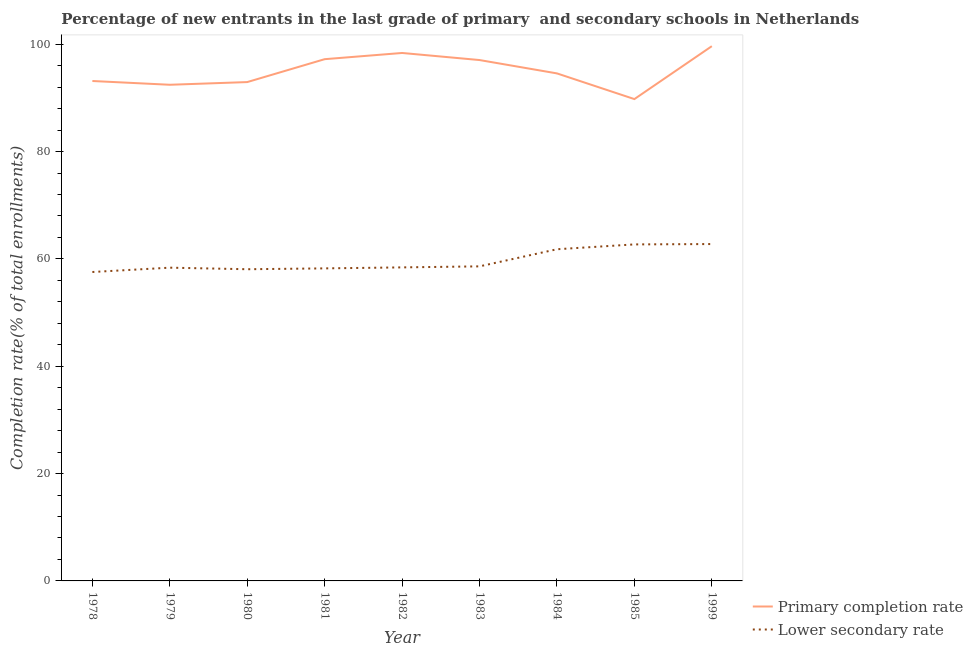How many different coloured lines are there?
Keep it short and to the point. 2. Is the number of lines equal to the number of legend labels?
Provide a succinct answer. Yes. What is the completion rate in primary schools in 1983?
Offer a very short reply. 97.05. Across all years, what is the maximum completion rate in secondary schools?
Offer a terse response. 62.77. Across all years, what is the minimum completion rate in primary schools?
Offer a terse response. 89.78. In which year was the completion rate in secondary schools minimum?
Your response must be concise. 1978. What is the total completion rate in secondary schools in the graph?
Your response must be concise. 536.54. What is the difference between the completion rate in secondary schools in 1985 and that in 1999?
Your answer should be compact. -0.07. What is the difference between the completion rate in primary schools in 1983 and the completion rate in secondary schools in 1999?
Keep it short and to the point. 34.28. What is the average completion rate in secondary schools per year?
Your response must be concise. 59.62. In the year 1999, what is the difference between the completion rate in primary schools and completion rate in secondary schools?
Your response must be concise. 36.87. What is the ratio of the completion rate in secondary schools in 1978 to that in 1999?
Offer a terse response. 0.92. What is the difference between the highest and the second highest completion rate in secondary schools?
Your response must be concise. 0.07. What is the difference between the highest and the lowest completion rate in primary schools?
Provide a succinct answer. 9.86. In how many years, is the completion rate in secondary schools greater than the average completion rate in secondary schools taken over all years?
Your answer should be compact. 3. Is the completion rate in primary schools strictly less than the completion rate in secondary schools over the years?
Ensure brevity in your answer.  No. How many lines are there?
Ensure brevity in your answer.  2. How many years are there in the graph?
Provide a short and direct response. 9. What is the difference between two consecutive major ticks on the Y-axis?
Your answer should be very brief. 20. Are the values on the major ticks of Y-axis written in scientific E-notation?
Your answer should be compact. No. Does the graph contain any zero values?
Give a very brief answer. No. Does the graph contain grids?
Provide a succinct answer. No. Where does the legend appear in the graph?
Offer a terse response. Bottom right. How many legend labels are there?
Your response must be concise. 2. What is the title of the graph?
Offer a very short reply. Percentage of new entrants in the last grade of primary  and secondary schools in Netherlands. What is the label or title of the X-axis?
Provide a succinct answer. Year. What is the label or title of the Y-axis?
Keep it short and to the point. Completion rate(% of total enrollments). What is the Completion rate(% of total enrollments) in Primary completion rate in 1978?
Provide a short and direct response. 93.15. What is the Completion rate(% of total enrollments) in Lower secondary rate in 1978?
Your answer should be compact. 57.56. What is the Completion rate(% of total enrollments) in Primary completion rate in 1979?
Keep it short and to the point. 92.45. What is the Completion rate(% of total enrollments) in Lower secondary rate in 1979?
Keep it short and to the point. 58.37. What is the Completion rate(% of total enrollments) of Primary completion rate in 1980?
Keep it short and to the point. 92.95. What is the Completion rate(% of total enrollments) in Lower secondary rate in 1980?
Ensure brevity in your answer.  58.08. What is the Completion rate(% of total enrollments) of Primary completion rate in 1981?
Ensure brevity in your answer.  97.21. What is the Completion rate(% of total enrollments) in Lower secondary rate in 1981?
Your answer should be compact. 58.23. What is the Completion rate(% of total enrollments) of Primary completion rate in 1982?
Give a very brief answer. 98.37. What is the Completion rate(% of total enrollments) in Lower secondary rate in 1982?
Your answer should be compact. 58.42. What is the Completion rate(% of total enrollments) of Primary completion rate in 1983?
Your answer should be very brief. 97.05. What is the Completion rate(% of total enrollments) of Lower secondary rate in 1983?
Keep it short and to the point. 58.61. What is the Completion rate(% of total enrollments) of Primary completion rate in 1984?
Ensure brevity in your answer.  94.56. What is the Completion rate(% of total enrollments) in Lower secondary rate in 1984?
Your response must be concise. 61.8. What is the Completion rate(% of total enrollments) in Primary completion rate in 1985?
Offer a very short reply. 89.78. What is the Completion rate(% of total enrollments) in Lower secondary rate in 1985?
Your response must be concise. 62.7. What is the Completion rate(% of total enrollments) of Primary completion rate in 1999?
Provide a succinct answer. 99.64. What is the Completion rate(% of total enrollments) of Lower secondary rate in 1999?
Your answer should be very brief. 62.77. Across all years, what is the maximum Completion rate(% of total enrollments) of Primary completion rate?
Your answer should be very brief. 99.64. Across all years, what is the maximum Completion rate(% of total enrollments) in Lower secondary rate?
Provide a short and direct response. 62.77. Across all years, what is the minimum Completion rate(% of total enrollments) of Primary completion rate?
Your answer should be compact. 89.78. Across all years, what is the minimum Completion rate(% of total enrollments) of Lower secondary rate?
Keep it short and to the point. 57.56. What is the total Completion rate(% of total enrollments) in Primary completion rate in the graph?
Provide a short and direct response. 855.16. What is the total Completion rate(% of total enrollments) in Lower secondary rate in the graph?
Give a very brief answer. 536.54. What is the difference between the Completion rate(% of total enrollments) of Primary completion rate in 1978 and that in 1979?
Ensure brevity in your answer.  0.7. What is the difference between the Completion rate(% of total enrollments) in Lower secondary rate in 1978 and that in 1979?
Your response must be concise. -0.81. What is the difference between the Completion rate(% of total enrollments) of Primary completion rate in 1978 and that in 1980?
Provide a succinct answer. 0.2. What is the difference between the Completion rate(% of total enrollments) in Lower secondary rate in 1978 and that in 1980?
Keep it short and to the point. -0.52. What is the difference between the Completion rate(% of total enrollments) of Primary completion rate in 1978 and that in 1981?
Offer a terse response. -4.07. What is the difference between the Completion rate(% of total enrollments) in Lower secondary rate in 1978 and that in 1981?
Provide a short and direct response. -0.67. What is the difference between the Completion rate(% of total enrollments) of Primary completion rate in 1978 and that in 1982?
Offer a terse response. -5.22. What is the difference between the Completion rate(% of total enrollments) of Lower secondary rate in 1978 and that in 1982?
Offer a very short reply. -0.86. What is the difference between the Completion rate(% of total enrollments) of Primary completion rate in 1978 and that in 1983?
Provide a succinct answer. -3.9. What is the difference between the Completion rate(% of total enrollments) in Lower secondary rate in 1978 and that in 1983?
Your answer should be compact. -1.05. What is the difference between the Completion rate(% of total enrollments) of Primary completion rate in 1978 and that in 1984?
Your response must be concise. -1.42. What is the difference between the Completion rate(% of total enrollments) of Lower secondary rate in 1978 and that in 1984?
Offer a very short reply. -4.24. What is the difference between the Completion rate(% of total enrollments) of Primary completion rate in 1978 and that in 1985?
Your answer should be very brief. 3.37. What is the difference between the Completion rate(% of total enrollments) in Lower secondary rate in 1978 and that in 1985?
Provide a succinct answer. -5.14. What is the difference between the Completion rate(% of total enrollments) in Primary completion rate in 1978 and that in 1999?
Provide a succinct answer. -6.49. What is the difference between the Completion rate(% of total enrollments) of Lower secondary rate in 1978 and that in 1999?
Give a very brief answer. -5.21. What is the difference between the Completion rate(% of total enrollments) of Primary completion rate in 1979 and that in 1980?
Ensure brevity in your answer.  -0.5. What is the difference between the Completion rate(% of total enrollments) in Lower secondary rate in 1979 and that in 1980?
Offer a terse response. 0.29. What is the difference between the Completion rate(% of total enrollments) of Primary completion rate in 1979 and that in 1981?
Keep it short and to the point. -4.77. What is the difference between the Completion rate(% of total enrollments) of Lower secondary rate in 1979 and that in 1981?
Keep it short and to the point. 0.13. What is the difference between the Completion rate(% of total enrollments) of Primary completion rate in 1979 and that in 1982?
Your answer should be very brief. -5.92. What is the difference between the Completion rate(% of total enrollments) of Lower secondary rate in 1979 and that in 1982?
Keep it short and to the point. -0.05. What is the difference between the Completion rate(% of total enrollments) in Primary completion rate in 1979 and that in 1983?
Offer a very short reply. -4.6. What is the difference between the Completion rate(% of total enrollments) in Lower secondary rate in 1979 and that in 1983?
Your answer should be compact. -0.24. What is the difference between the Completion rate(% of total enrollments) in Primary completion rate in 1979 and that in 1984?
Keep it short and to the point. -2.12. What is the difference between the Completion rate(% of total enrollments) of Lower secondary rate in 1979 and that in 1984?
Offer a terse response. -3.43. What is the difference between the Completion rate(% of total enrollments) in Primary completion rate in 1979 and that in 1985?
Provide a short and direct response. 2.67. What is the difference between the Completion rate(% of total enrollments) of Lower secondary rate in 1979 and that in 1985?
Give a very brief answer. -4.34. What is the difference between the Completion rate(% of total enrollments) of Primary completion rate in 1979 and that in 1999?
Ensure brevity in your answer.  -7.19. What is the difference between the Completion rate(% of total enrollments) of Lower secondary rate in 1979 and that in 1999?
Offer a terse response. -4.4. What is the difference between the Completion rate(% of total enrollments) in Primary completion rate in 1980 and that in 1981?
Your answer should be very brief. -4.27. What is the difference between the Completion rate(% of total enrollments) in Lower secondary rate in 1980 and that in 1981?
Make the answer very short. -0.16. What is the difference between the Completion rate(% of total enrollments) in Primary completion rate in 1980 and that in 1982?
Give a very brief answer. -5.42. What is the difference between the Completion rate(% of total enrollments) of Lower secondary rate in 1980 and that in 1982?
Your answer should be compact. -0.34. What is the difference between the Completion rate(% of total enrollments) in Primary completion rate in 1980 and that in 1983?
Your answer should be very brief. -4.1. What is the difference between the Completion rate(% of total enrollments) of Lower secondary rate in 1980 and that in 1983?
Offer a terse response. -0.54. What is the difference between the Completion rate(% of total enrollments) of Primary completion rate in 1980 and that in 1984?
Offer a very short reply. -1.62. What is the difference between the Completion rate(% of total enrollments) in Lower secondary rate in 1980 and that in 1984?
Offer a very short reply. -3.72. What is the difference between the Completion rate(% of total enrollments) in Primary completion rate in 1980 and that in 1985?
Keep it short and to the point. 3.17. What is the difference between the Completion rate(% of total enrollments) of Lower secondary rate in 1980 and that in 1985?
Your response must be concise. -4.63. What is the difference between the Completion rate(% of total enrollments) of Primary completion rate in 1980 and that in 1999?
Your answer should be compact. -6.69. What is the difference between the Completion rate(% of total enrollments) of Lower secondary rate in 1980 and that in 1999?
Keep it short and to the point. -4.69. What is the difference between the Completion rate(% of total enrollments) of Primary completion rate in 1981 and that in 1982?
Ensure brevity in your answer.  -1.16. What is the difference between the Completion rate(% of total enrollments) of Lower secondary rate in 1981 and that in 1982?
Give a very brief answer. -0.18. What is the difference between the Completion rate(% of total enrollments) in Primary completion rate in 1981 and that in 1983?
Provide a short and direct response. 0.16. What is the difference between the Completion rate(% of total enrollments) in Lower secondary rate in 1981 and that in 1983?
Provide a succinct answer. -0.38. What is the difference between the Completion rate(% of total enrollments) of Primary completion rate in 1981 and that in 1984?
Offer a terse response. 2.65. What is the difference between the Completion rate(% of total enrollments) in Lower secondary rate in 1981 and that in 1984?
Offer a terse response. -3.56. What is the difference between the Completion rate(% of total enrollments) in Primary completion rate in 1981 and that in 1985?
Provide a succinct answer. 7.44. What is the difference between the Completion rate(% of total enrollments) in Lower secondary rate in 1981 and that in 1985?
Your response must be concise. -4.47. What is the difference between the Completion rate(% of total enrollments) of Primary completion rate in 1981 and that in 1999?
Keep it short and to the point. -2.42. What is the difference between the Completion rate(% of total enrollments) of Lower secondary rate in 1981 and that in 1999?
Your answer should be compact. -4.53. What is the difference between the Completion rate(% of total enrollments) of Primary completion rate in 1982 and that in 1983?
Ensure brevity in your answer.  1.32. What is the difference between the Completion rate(% of total enrollments) of Lower secondary rate in 1982 and that in 1983?
Your response must be concise. -0.19. What is the difference between the Completion rate(% of total enrollments) of Primary completion rate in 1982 and that in 1984?
Your answer should be compact. 3.81. What is the difference between the Completion rate(% of total enrollments) of Lower secondary rate in 1982 and that in 1984?
Offer a terse response. -3.38. What is the difference between the Completion rate(% of total enrollments) of Primary completion rate in 1982 and that in 1985?
Provide a succinct answer. 8.59. What is the difference between the Completion rate(% of total enrollments) of Lower secondary rate in 1982 and that in 1985?
Offer a very short reply. -4.28. What is the difference between the Completion rate(% of total enrollments) of Primary completion rate in 1982 and that in 1999?
Keep it short and to the point. -1.27. What is the difference between the Completion rate(% of total enrollments) in Lower secondary rate in 1982 and that in 1999?
Offer a very short reply. -4.35. What is the difference between the Completion rate(% of total enrollments) in Primary completion rate in 1983 and that in 1984?
Keep it short and to the point. 2.49. What is the difference between the Completion rate(% of total enrollments) in Lower secondary rate in 1983 and that in 1984?
Ensure brevity in your answer.  -3.19. What is the difference between the Completion rate(% of total enrollments) of Primary completion rate in 1983 and that in 1985?
Keep it short and to the point. 7.27. What is the difference between the Completion rate(% of total enrollments) in Lower secondary rate in 1983 and that in 1985?
Your response must be concise. -4.09. What is the difference between the Completion rate(% of total enrollments) of Primary completion rate in 1983 and that in 1999?
Offer a very short reply. -2.59. What is the difference between the Completion rate(% of total enrollments) of Lower secondary rate in 1983 and that in 1999?
Offer a very short reply. -4.16. What is the difference between the Completion rate(% of total enrollments) in Primary completion rate in 1984 and that in 1985?
Your answer should be compact. 4.79. What is the difference between the Completion rate(% of total enrollments) in Lower secondary rate in 1984 and that in 1985?
Provide a short and direct response. -0.9. What is the difference between the Completion rate(% of total enrollments) of Primary completion rate in 1984 and that in 1999?
Your answer should be very brief. -5.07. What is the difference between the Completion rate(% of total enrollments) of Lower secondary rate in 1984 and that in 1999?
Keep it short and to the point. -0.97. What is the difference between the Completion rate(% of total enrollments) of Primary completion rate in 1985 and that in 1999?
Your answer should be very brief. -9.86. What is the difference between the Completion rate(% of total enrollments) in Lower secondary rate in 1985 and that in 1999?
Your response must be concise. -0.07. What is the difference between the Completion rate(% of total enrollments) of Primary completion rate in 1978 and the Completion rate(% of total enrollments) of Lower secondary rate in 1979?
Offer a very short reply. 34.78. What is the difference between the Completion rate(% of total enrollments) of Primary completion rate in 1978 and the Completion rate(% of total enrollments) of Lower secondary rate in 1980?
Give a very brief answer. 35.07. What is the difference between the Completion rate(% of total enrollments) in Primary completion rate in 1978 and the Completion rate(% of total enrollments) in Lower secondary rate in 1981?
Ensure brevity in your answer.  34.91. What is the difference between the Completion rate(% of total enrollments) of Primary completion rate in 1978 and the Completion rate(% of total enrollments) of Lower secondary rate in 1982?
Make the answer very short. 34.73. What is the difference between the Completion rate(% of total enrollments) of Primary completion rate in 1978 and the Completion rate(% of total enrollments) of Lower secondary rate in 1983?
Offer a very short reply. 34.54. What is the difference between the Completion rate(% of total enrollments) in Primary completion rate in 1978 and the Completion rate(% of total enrollments) in Lower secondary rate in 1984?
Ensure brevity in your answer.  31.35. What is the difference between the Completion rate(% of total enrollments) of Primary completion rate in 1978 and the Completion rate(% of total enrollments) of Lower secondary rate in 1985?
Give a very brief answer. 30.45. What is the difference between the Completion rate(% of total enrollments) of Primary completion rate in 1978 and the Completion rate(% of total enrollments) of Lower secondary rate in 1999?
Make the answer very short. 30.38. What is the difference between the Completion rate(% of total enrollments) of Primary completion rate in 1979 and the Completion rate(% of total enrollments) of Lower secondary rate in 1980?
Offer a terse response. 34.37. What is the difference between the Completion rate(% of total enrollments) of Primary completion rate in 1979 and the Completion rate(% of total enrollments) of Lower secondary rate in 1981?
Your answer should be very brief. 34.21. What is the difference between the Completion rate(% of total enrollments) in Primary completion rate in 1979 and the Completion rate(% of total enrollments) in Lower secondary rate in 1982?
Your response must be concise. 34.03. What is the difference between the Completion rate(% of total enrollments) of Primary completion rate in 1979 and the Completion rate(% of total enrollments) of Lower secondary rate in 1983?
Keep it short and to the point. 33.84. What is the difference between the Completion rate(% of total enrollments) of Primary completion rate in 1979 and the Completion rate(% of total enrollments) of Lower secondary rate in 1984?
Keep it short and to the point. 30.65. What is the difference between the Completion rate(% of total enrollments) of Primary completion rate in 1979 and the Completion rate(% of total enrollments) of Lower secondary rate in 1985?
Keep it short and to the point. 29.75. What is the difference between the Completion rate(% of total enrollments) in Primary completion rate in 1979 and the Completion rate(% of total enrollments) in Lower secondary rate in 1999?
Your answer should be compact. 29.68. What is the difference between the Completion rate(% of total enrollments) of Primary completion rate in 1980 and the Completion rate(% of total enrollments) of Lower secondary rate in 1981?
Your response must be concise. 34.71. What is the difference between the Completion rate(% of total enrollments) of Primary completion rate in 1980 and the Completion rate(% of total enrollments) of Lower secondary rate in 1982?
Make the answer very short. 34.53. What is the difference between the Completion rate(% of total enrollments) of Primary completion rate in 1980 and the Completion rate(% of total enrollments) of Lower secondary rate in 1983?
Your answer should be very brief. 34.34. What is the difference between the Completion rate(% of total enrollments) in Primary completion rate in 1980 and the Completion rate(% of total enrollments) in Lower secondary rate in 1984?
Provide a succinct answer. 31.15. What is the difference between the Completion rate(% of total enrollments) in Primary completion rate in 1980 and the Completion rate(% of total enrollments) in Lower secondary rate in 1985?
Keep it short and to the point. 30.25. What is the difference between the Completion rate(% of total enrollments) of Primary completion rate in 1980 and the Completion rate(% of total enrollments) of Lower secondary rate in 1999?
Offer a terse response. 30.18. What is the difference between the Completion rate(% of total enrollments) in Primary completion rate in 1981 and the Completion rate(% of total enrollments) in Lower secondary rate in 1982?
Keep it short and to the point. 38.8. What is the difference between the Completion rate(% of total enrollments) of Primary completion rate in 1981 and the Completion rate(% of total enrollments) of Lower secondary rate in 1983?
Ensure brevity in your answer.  38.6. What is the difference between the Completion rate(% of total enrollments) of Primary completion rate in 1981 and the Completion rate(% of total enrollments) of Lower secondary rate in 1984?
Provide a short and direct response. 35.41. What is the difference between the Completion rate(% of total enrollments) in Primary completion rate in 1981 and the Completion rate(% of total enrollments) in Lower secondary rate in 1985?
Ensure brevity in your answer.  34.51. What is the difference between the Completion rate(% of total enrollments) of Primary completion rate in 1981 and the Completion rate(% of total enrollments) of Lower secondary rate in 1999?
Make the answer very short. 34.45. What is the difference between the Completion rate(% of total enrollments) of Primary completion rate in 1982 and the Completion rate(% of total enrollments) of Lower secondary rate in 1983?
Make the answer very short. 39.76. What is the difference between the Completion rate(% of total enrollments) in Primary completion rate in 1982 and the Completion rate(% of total enrollments) in Lower secondary rate in 1984?
Provide a short and direct response. 36.57. What is the difference between the Completion rate(% of total enrollments) of Primary completion rate in 1982 and the Completion rate(% of total enrollments) of Lower secondary rate in 1985?
Keep it short and to the point. 35.67. What is the difference between the Completion rate(% of total enrollments) of Primary completion rate in 1982 and the Completion rate(% of total enrollments) of Lower secondary rate in 1999?
Ensure brevity in your answer.  35.6. What is the difference between the Completion rate(% of total enrollments) in Primary completion rate in 1983 and the Completion rate(% of total enrollments) in Lower secondary rate in 1984?
Give a very brief answer. 35.25. What is the difference between the Completion rate(% of total enrollments) in Primary completion rate in 1983 and the Completion rate(% of total enrollments) in Lower secondary rate in 1985?
Provide a succinct answer. 34.35. What is the difference between the Completion rate(% of total enrollments) of Primary completion rate in 1983 and the Completion rate(% of total enrollments) of Lower secondary rate in 1999?
Make the answer very short. 34.28. What is the difference between the Completion rate(% of total enrollments) in Primary completion rate in 1984 and the Completion rate(% of total enrollments) in Lower secondary rate in 1985?
Offer a terse response. 31.86. What is the difference between the Completion rate(% of total enrollments) of Primary completion rate in 1984 and the Completion rate(% of total enrollments) of Lower secondary rate in 1999?
Ensure brevity in your answer.  31.8. What is the difference between the Completion rate(% of total enrollments) in Primary completion rate in 1985 and the Completion rate(% of total enrollments) in Lower secondary rate in 1999?
Your answer should be very brief. 27.01. What is the average Completion rate(% of total enrollments) of Primary completion rate per year?
Your answer should be very brief. 95.02. What is the average Completion rate(% of total enrollments) in Lower secondary rate per year?
Your answer should be compact. 59.62. In the year 1978, what is the difference between the Completion rate(% of total enrollments) in Primary completion rate and Completion rate(% of total enrollments) in Lower secondary rate?
Your answer should be compact. 35.59. In the year 1979, what is the difference between the Completion rate(% of total enrollments) of Primary completion rate and Completion rate(% of total enrollments) of Lower secondary rate?
Your answer should be very brief. 34.08. In the year 1980, what is the difference between the Completion rate(% of total enrollments) in Primary completion rate and Completion rate(% of total enrollments) in Lower secondary rate?
Your answer should be compact. 34.87. In the year 1981, what is the difference between the Completion rate(% of total enrollments) of Primary completion rate and Completion rate(% of total enrollments) of Lower secondary rate?
Offer a terse response. 38.98. In the year 1982, what is the difference between the Completion rate(% of total enrollments) of Primary completion rate and Completion rate(% of total enrollments) of Lower secondary rate?
Keep it short and to the point. 39.95. In the year 1983, what is the difference between the Completion rate(% of total enrollments) in Primary completion rate and Completion rate(% of total enrollments) in Lower secondary rate?
Ensure brevity in your answer.  38.44. In the year 1984, what is the difference between the Completion rate(% of total enrollments) in Primary completion rate and Completion rate(% of total enrollments) in Lower secondary rate?
Give a very brief answer. 32.77. In the year 1985, what is the difference between the Completion rate(% of total enrollments) in Primary completion rate and Completion rate(% of total enrollments) in Lower secondary rate?
Your response must be concise. 27.08. In the year 1999, what is the difference between the Completion rate(% of total enrollments) of Primary completion rate and Completion rate(% of total enrollments) of Lower secondary rate?
Offer a very short reply. 36.87. What is the ratio of the Completion rate(% of total enrollments) in Primary completion rate in 1978 to that in 1979?
Offer a terse response. 1.01. What is the ratio of the Completion rate(% of total enrollments) in Lower secondary rate in 1978 to that in 1979?
Give a very brief answer. 0.99. What is the ratio of the Completion rate(% of total enrollments) in Lower secondary rate in 1978 to that in 1980?
Your answer should be compact. 0.99. What is the ratio of the Completion rate(% of total enrollments) in Primary completion rate in 1978 to that in 1981?
Provide a succinct answer. 0.96. What is the ratio of the Completion rate(% of total enrollments) of Lower secondary rate in 1978 to that in 1981?
Your answer should be compact. 0.99. What is the ratio of the Completion rate(% of total enrollments) of Primary completion rate in 1978 to that in 1982?
Offer a terse response. 0.95. What is the ratio of the Completion rate(% of total enrollments) of Primary completion rate in 1978 to that in 1983?
Ensure brevity in your answer.  0.96. What is the ratio of the Completion rate(% of total enrollments) of Lower secondary rate in 1978 to that in 1983?
Your answer should be very brief. 0.98. What is the ratio of the Completion rate(% of total enrollments) of Primary completion rate in 1978 to that in 1984?
Offer a very short reply. 0.98. What is the ratio of the Completion rate(% of total enrollments) of Lower secondary rate in 1978 to that in 1984?
Your response must be concise. 0.93. What is the ratio of the Completion rate(% of total enrollments) of Primary completion rate in 1978 to that in 1985?
Give a very brief answer. 1.04. What is the ratio of the Completion rate(% of total enrollments) in Lower secondary rate in 1978 to that in 1985?
Your answer should be compact. 0.92. What is the ratio of the Completion rate(% of total enrollments) of Primary completion rate in 1978 to that in 1999?
Give a very brief answer. 0.93. What is the ratio of the Completion rate(% of total enrollments) in Lower secondary rate in 1978 to that in 1999?
Your response must be concise. 0.92. What is the ratio of the Completion rate(% of total enrollments) in Primary completion rate in 1979 to that in 1980?
Keep it short and to the point. 0.99. What is the ratio of the Completion rate(% of total enrollments) of Primary completion rate in 1979 to that in 1981?
Make the answer very short. 0.95. What is the ratio of the Completion rate(% of total enrollments) of Primary completion rate in 1979 to that in 1982?
Offer a very short reply. 0.94. What is the ratio of the Completion rate(% of total enrollments) of Primary completion rate in 1979 to that in 1983?
Ensure brevity in your answer.  0.95. What is the ratio of the Completion rate(% of total enrollments) of Lower secondary rate in 1979 to that in 1983?
Your answer should be very brief. 1. What is the ratio of the Completion rate(% of total enrollments) of Primary completion rate in 1979 to that in 1984?
Offer a very short reply. 0.98. What is the ratio of the Completion rate(% of total enrollments) in Primary completion rate in 1979 to that in 1985?
Offer a terse response. 1.03. What is the ratio of the Completion rate(% of total enrollments) in Lower secondary rate in 1979 to that in 1985?
Provide a succinct answer. 0.93. What is the ratio of the Completion rate(% of total enrollments) of Primary completion rate in 1979 to that in 1999?
Your answer should be very brief. 0.93. What is the ratio of the Completion rate(% of total enrollments) in Lower secondary rate in 1979 to that in 1999?
Offer a very short reply. 0.93. What is the ratio of the Completion rate(% of total enrollments) in Primary completion rate in 1980 to that in 1981?
Provide a short and direct response. 0.96. What is the ratio of the Completion rate(% of total enrollments) in Primary completion rate in 1980 to that in 1982?
Keep it short and to the point. 0.94. What is the ratio of the Completion rate(% of total enrollments) in Primary completion rate in 1980 to that in 1983?
Provide a succinct answer. 0.96. What is the ratio of the Completion rate(% of total enrollments) of Lower secondary rate in 1980 to that in 1983?
Make the answer very short. 0.99. What is the ratio of the Completion rate(% of total enrollments) of Primary completion rate in 1980 to that in 1984?
Keep it short and to the point. 0.98. What is the ratio of the Completion rate(% of total enrollments) of Lower secondary rate in 1980 to that in 1984?
Offer a terse response. 0.94. What is the ratio of the Completion rate(% of total enrollments) of Primary completion rate in 1980 to that in 1985?
Your response must be concise. 1.04. What is the ratio of the Completion rate(% of total enrollments) of Lower secondary rate in 1980 to that in 1985?
Your answer should be compact. 0.93. What is the ratio of the Completion rate(% of total enrollments) of Primary completion rate in 1980 to that in 1999?
Make the answer very short. 0.93. What is the ratio of the Completion rate(% of total enrollments) in Lower secondary rate in 1980 to that in 1999?
Give a very brief answer. 0.93. What is the ratio of the Completion rate(% of total enrollments) in Primary completion rate in 1981 to that in 1982?
Your answer should be very brief. 0.99. What is the ratio of the Completion rate(% of total enrollments) of Primary completion rate in 1981 to that in 1983?
Keep it short and to the point. 1. What is the ratio of the Completion rate(% of total enrollments) in Primary completion rate in 1981 to that in 1984?
Your answer should be very brief. 1.03. What is the ratio of the Completion rate(% of total enrollments) of Lower secondary rate in 1981 to that in 1984?
Offer a very short reply. 0.94. What is the ratio of the Completion rate(% of total enrollments) in Primary completion rate in 1981 to that in 1985?
Your response must be concise. 1.08. What is the ratio of the Completion rate(% of total enrollments) in Lower secondary rate in 1981 to that in 1985?
Your answer should be compact. 0.93. What is the ratio of the Completion rate(% of total enrollments) of Primary completion rate in 1981 to that in 1999?
Your answer should be compact. 0.98. What is the ratio of the Completion rate(% of total enrollments) of Lower secondary rate in 1981 to that in 1999?
Your answer should be very brief. 0.93. What is the ratio of the Completion rate(% of total enrollments) in Primary completion rate in 1982 to that in 1983?
Offer a very short reply. 1.01. What is the ratio of the Completion rate(% of total enrollments) in Lower secondary rate in 1982 to that in 1983?
Make the answer very short. 1. What is the ratio of the Completion rate(% of total enrollments) of Primary completion rate in 1982 to that in 1984?
Keep it short and to the point. 1.04. What is the ratio of the Completion rate(% of total enrollments) of Lower secondary rate in 1982 to that in 1984?
Your response must be concise. 0.95. What is the ratio of the Completion rate(% of total enrollments) in Primary completion rate in 1982 to that in 1985?
Your answer should be compact. 1.1. What is the ratio of the Completion rate(% of total enrollments) of Lower secondary rate in 1982 to that in 1985?
Your response must be concise. 0.93. What is the ratio of the Completion rate(% of total enrollments) of Primary completion rate in 1982 to that in 1999?
Provide a short and direct response. 0.99. What is the ratio of the Completion rate(% of total enrollments) of Lower secondary rate in 1982 to that in 1999?
Provide a short and direct response. 0.93. What is the ratio of the Completion rate(% of total enrollments) in Primary completion rate in 1983 to that in 1984?
Your answer should be compact. 1.03. What is the ratio of the Completion rate(% of total enrollments) in Lower secondary rate in 1983 to that in 1984?
Your response must be concise. 0.95. What is the ratio of the Completion rate(% of total enrollments) of Primary completion rate in 1983 to that in 1985?
Provide a short and direct response. 1.08. What is the ratio of the Completion rate(% of total enrollments) in Lower secondary rate in 1983 to that in 1985?
Make the answer very short. 0.93. What is the ratio of the Completion rate(% of total enrollments) of Primary completion rate in 1983 to that in 1999?
Your answer should be compact. 0.97. What is the ratio of the Completion rate(% of total enrollments) in Lower secondary rate in 1983 to that in 1999?
Provide a succinct answer. 0.93. What is the ratio of the Completion rate(% of total enrollments) of Primary completion rate in 1984 to that in 1985?
Your answer should be very brief. 1.05. What is the ratio of the Completion rate(% of total enrollments) of Lower secondary rate in 1984 to that in 1985?
Ensure brevity in your answer.  0.99. What is the ratio of the Completion rate(% of total enrollments) of Primary completion rate in 1984 to that in 1999?
Ensure brevity in your answer.  0.95. What is the ratio of the Completion rate(% of total enrollments) of Lower secondary rate in 1984 to that in 1999?
Your answer should be very brief. 0.98. What is the ratio of the Completion rate(% of total enrollments) in Primary completion rate in 1985 to that in 1999?
Provide a short and direct response. 0.9. What is the ratio of the Completion rate(% of total enrollments) in Lower secondary rate in 1985 to that in 1999?
Your response must be concise. 1. What is the difference between the highest and the second highest Completion rate(% of total enrollments) in Primary completion rate?
Offer a very short reply. 1.27. What is the difference between the highest and the second highest Completion rate(% of total enrollments) in Lower secondary rate?
Offer a terse response. 0.07. What is the difference between the highest and the lowest Completion rate(% of total enrollments) of Primary completion rate?
Provide a short and direct response. 9.86. What is the difference between the highest and the lowest Completion rate(% of total enrollments) of Lower secondary rate?
Provide a succinct answer. 5.21. 